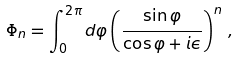Convert formula to latex. <formula><loc_0><loc_0><loc_500><loc_500>\Phi _ { n } = \int _ { 0 } ^ { 2 \pi } d \varphi \left ( \frac { \sin \varphi } { \cos \varphi + i \epsilon } \right ) ^ { n } \, ,</formula> 